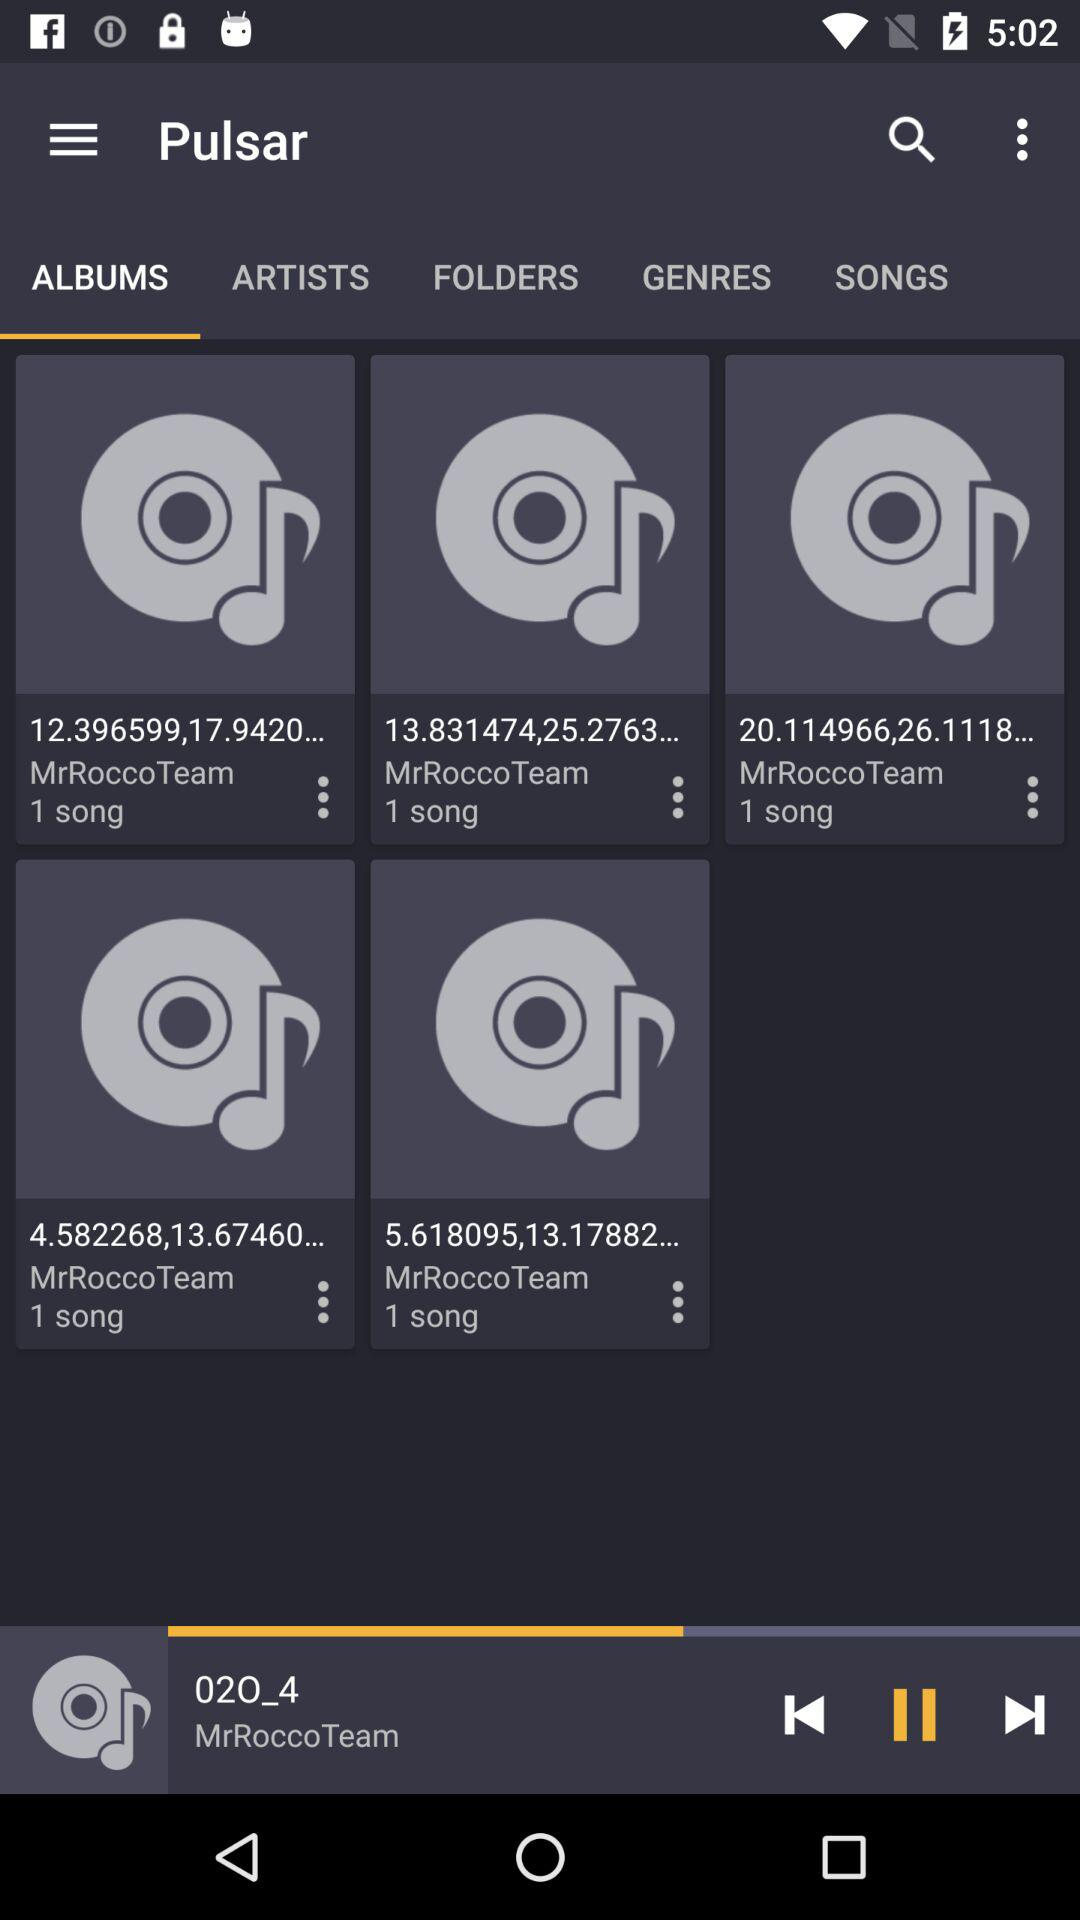What is the selected tab? The selected tab is "ALBUMS". 